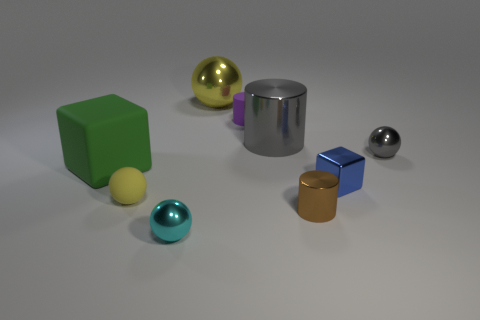Subtract all cyan blocks. Subtract all yellow balls. How many blocks are left? 2 Add 1 gray matte spheres. How many objects exist? 10 Subtract all cylinders. How many objects are left? 6 Add 2 red rubber cubes. How many red rubber cubes exist? 2 Subtract 0 purple blocks. How many objects are left? 9 Subtract all small metallic objects. Subtract all metallic cylinders. How many objects are left? 3 Add 1 big matte cubes. How many big matte cubes are left? 2 